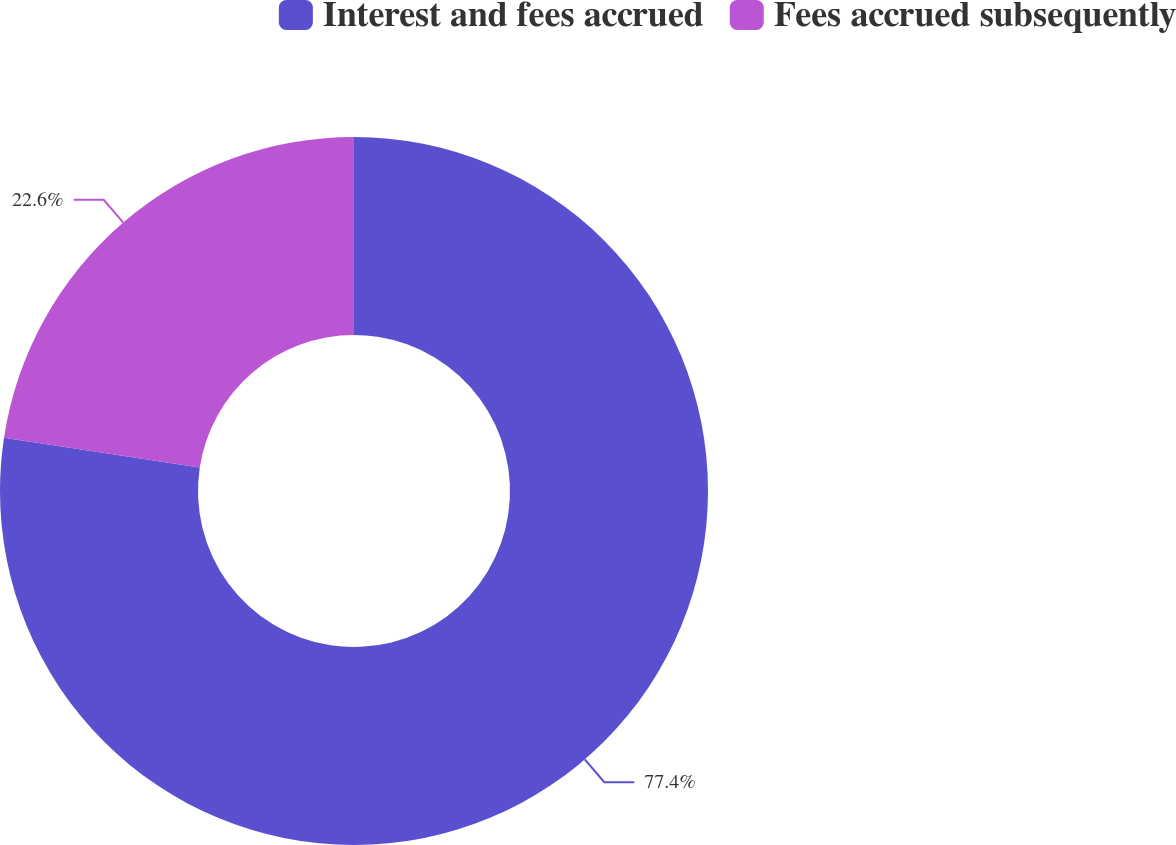Convert chart to OTSL. <chart><loc_0><loc_0><loc_500><loc_500><pie_chart><fcel>Interest and fees accrued<fcel>Fees accrued subsequently<nl><fcel>77.4%<fcel>22.6%<nl></chart> 